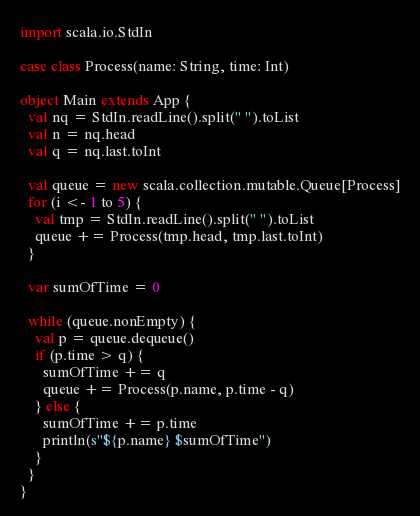Convert code to text. <code><loc_0><loc_0><loc_500><loc_500><_Scala_>import scala.io.StdIn

case class Process(name: String, time: Int)

object Main extends App {
  val nq = StdIn.readLine().split(" ").toList
  val n = nq.head
  val q = nq.last.toInt

  val queue = new scala.collection.mutable.Queue[Process]
  for (i <- 1 to 5) {
    val tmp = StdIn.readLine().split(" ").toList
    queue += Process(tmp.head, tmp.last.toInt)
  }

  var sumOfTime = 0

  while (queue.nonEmpty) {
    val p = queue.dequeue()
    if (p.time > q) {
      sumOfTime += q
      queue += Process(p.name, p.time - q)
    } else {
      sumOfTime += p.time
      println(s"${p.name} $sumOfTime")
    }
  }
}</code> 